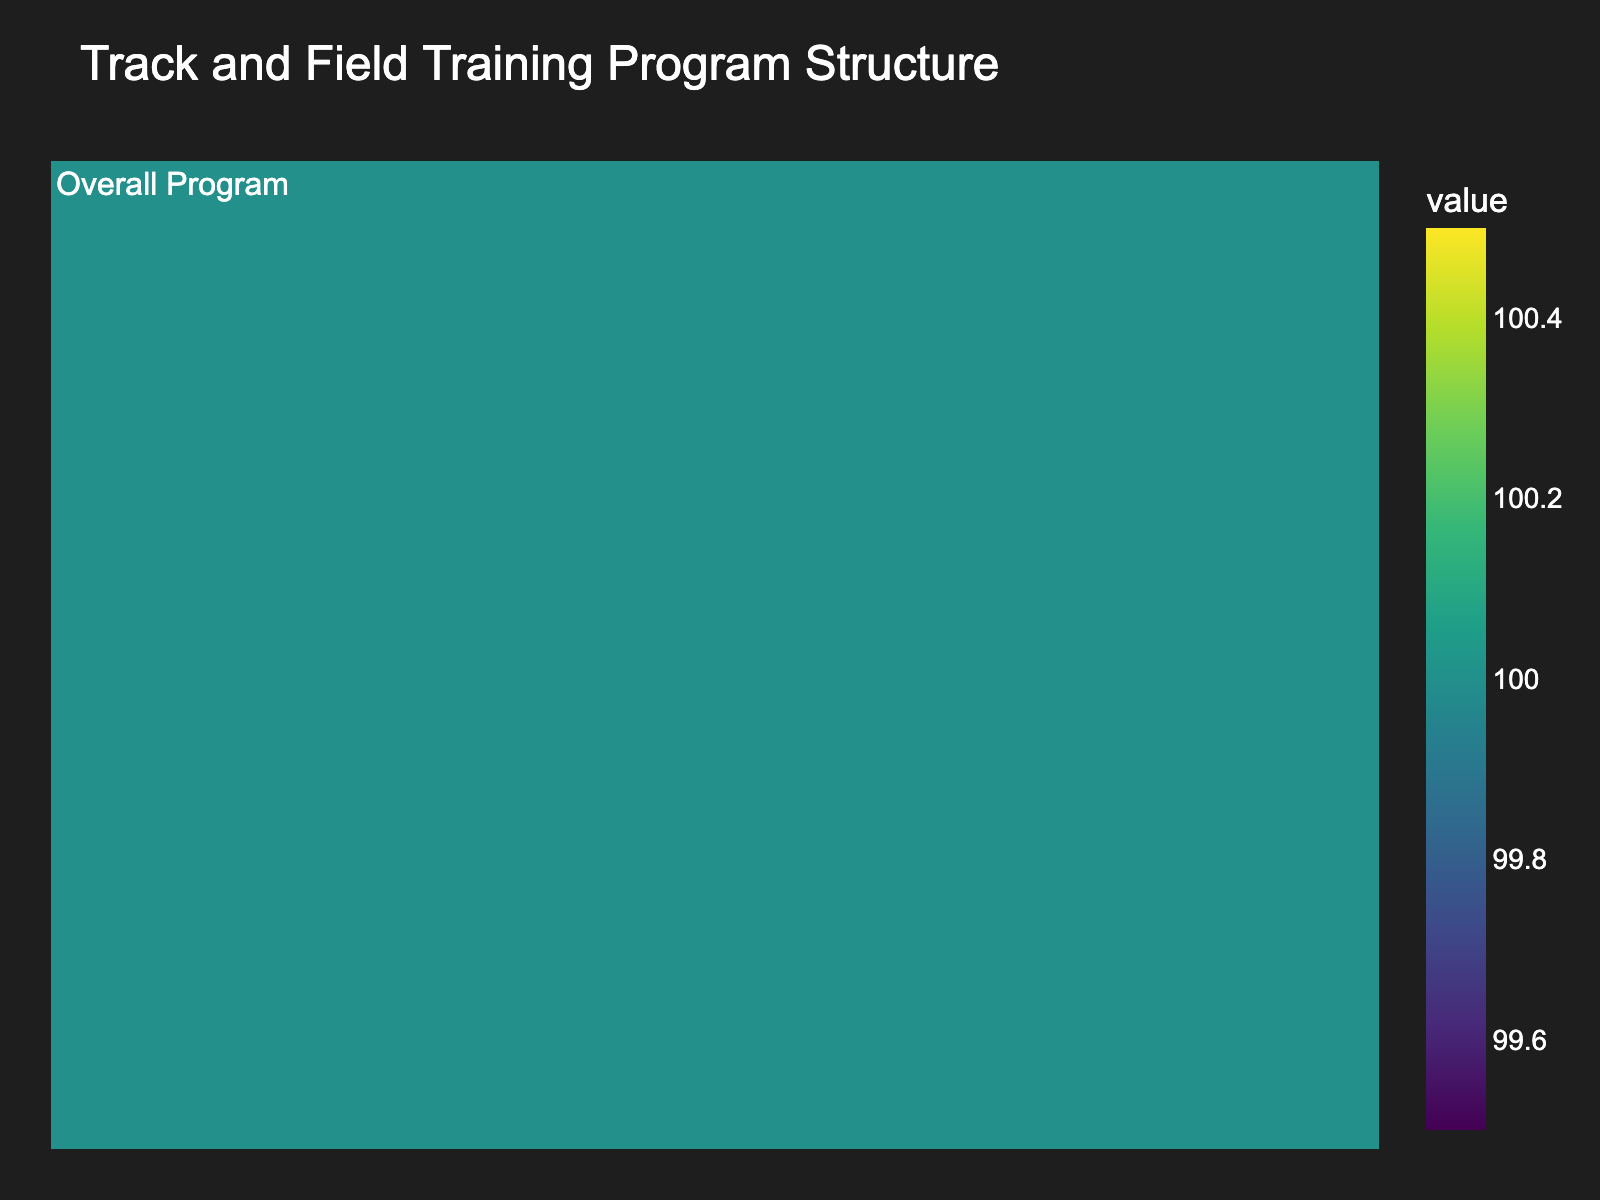What is the title of the figure? The title of the figure is displayed at the top and it serves to provide an overview of what the figure represents. Here, it is "Track and Field Training Program Structure."
Answer: Track and Field Training Program Structure What color scheme is used in the figure? The colors utilized in the chart are vibrant shades found in the 'viridis' color scale.
Answer: viridis What percentage of time is allocated to the overall program? The chart displays the percentage of time allocated next to the segment's label. The overall program is allocated 100%.
Answer: 100% How many levels of breakdown can be seen in the chart? Since the chart's data only includes an overall allocation without further breakdowns, the chart shows only one level.
Answer: 1 Is there any sub-activity that takes additional time allocation beyond the overall training program? By observing the figure, there are no additional sub-activities listed beyond the "Overall Program," indicating no further level of detail.
Answer: No How does the chart visually present the percentages allocated to different activities? The chart uses width and color intensity to show distribution. Since only one activity is displayed, the entire chart is filled by one color proportionally to 100%.
Answer: Width and color intensity Are there any missing data points that prevent the complete understanding of the training program? The chart only shows a single node "Overall Program" with no sub-activities, making it impossible to understand the detailed time allocation structure.
Answer: Yes What is the purpose of the hover template in the chart? The hover template enhances the user experience by providing detailed information when hovering over a segment, such as the label and value.
Answer: Detailed information Would the chart be more effective with additional data? Including more detailed sub-activities and their respective time allocations would provide a comprehensive view of the training structure.
Answer: Yes 